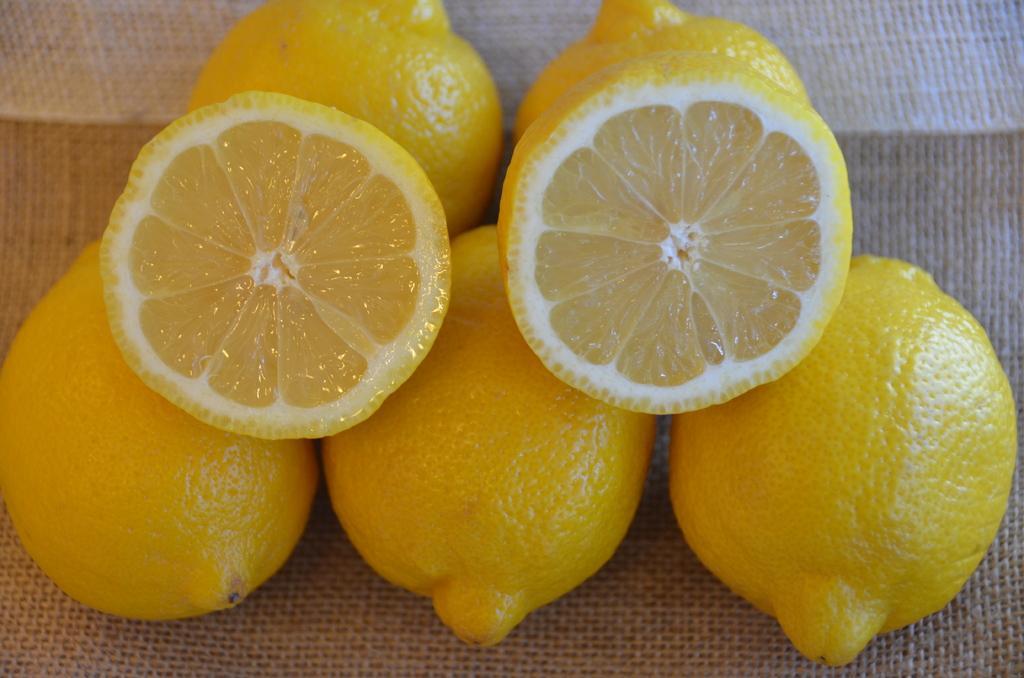Can you describe this image briefly? We can see lemons on the jute surface. 